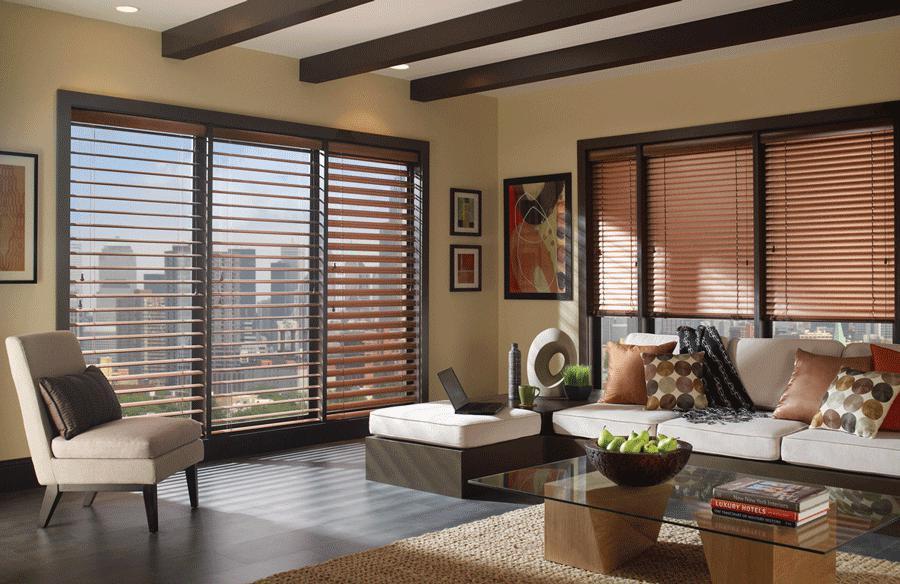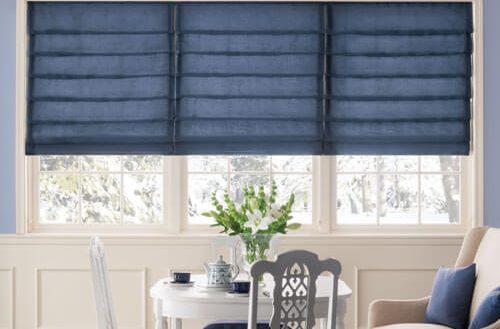The first image is the image on the left, the second image is the image on the right. Analyze the images presented: Is the assertion "There are exactly two window shades in the left image." valid? Answer yes or no. No. The first image is the image on the left, the second image is the image on the right. Examine the images to the left and right. Is the description "There are no more than three blinds." accurate? Answer yes or no. No. 